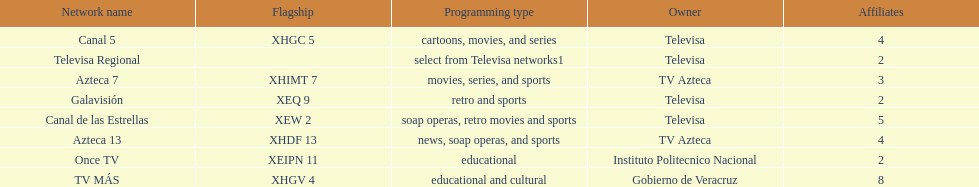Which is the only station with 8 affiliates? TV MÁS. 